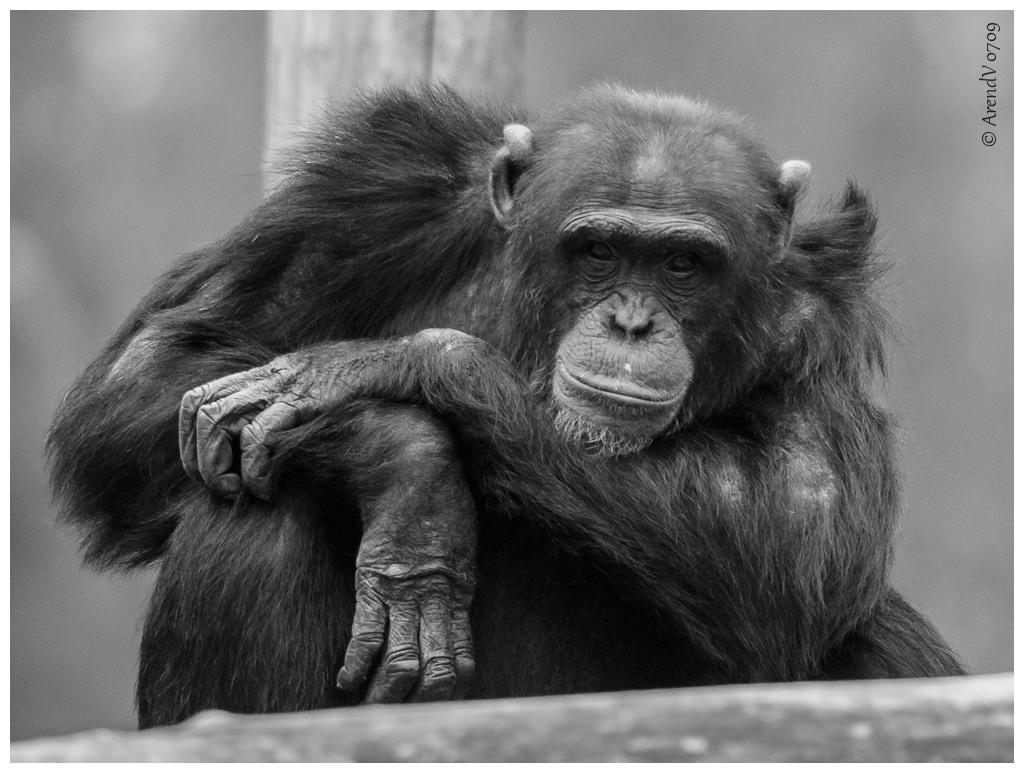Describe this image in one or two sentences. In this picture we can see a chimpanzee here, there is a blurry background here, at the right top we can see some text. 